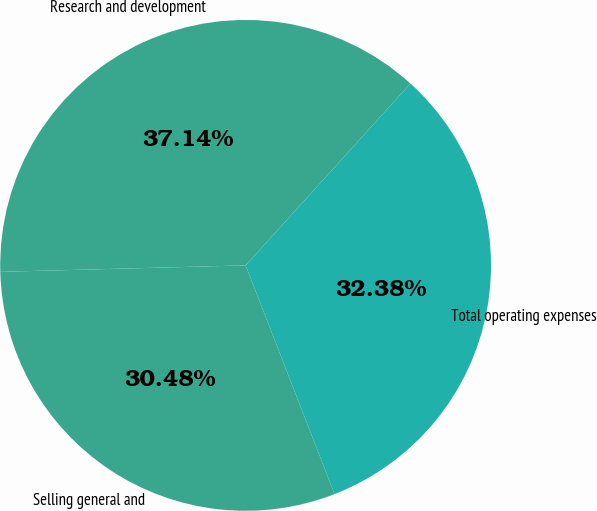<chart> <loc_0><loc_0><loc_500><loc_500><pie_chart><fcel>Research and development<fcel>Selling general and<fcel>Total operating expenses<nl><fcel>37.14%<fcel>30.48%<fcel>32.38%<nl></chart> 